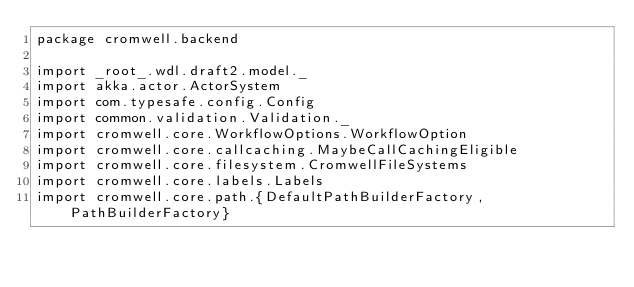<code> <loc_0><loc_0><loc_500><loc_500><_Scala_>package cromwell.backend

import _root_.wdl.draft2.model._
import akka.actor.ActorSystem
import com.typesafe.config.Config
import common.validation.Validation._
import cromwell.core.WorkflowOptions.WorkflowOption
import cromwell.core.callcaching.MaybeCallCachingEligible
import cromwell.core.filesystem.CromwellFileSystems
import cromwell.core.labels.Labels
import cromwell.core.path.{DefaultPathBuilderFactory, PathBuilderFactory}</code> 